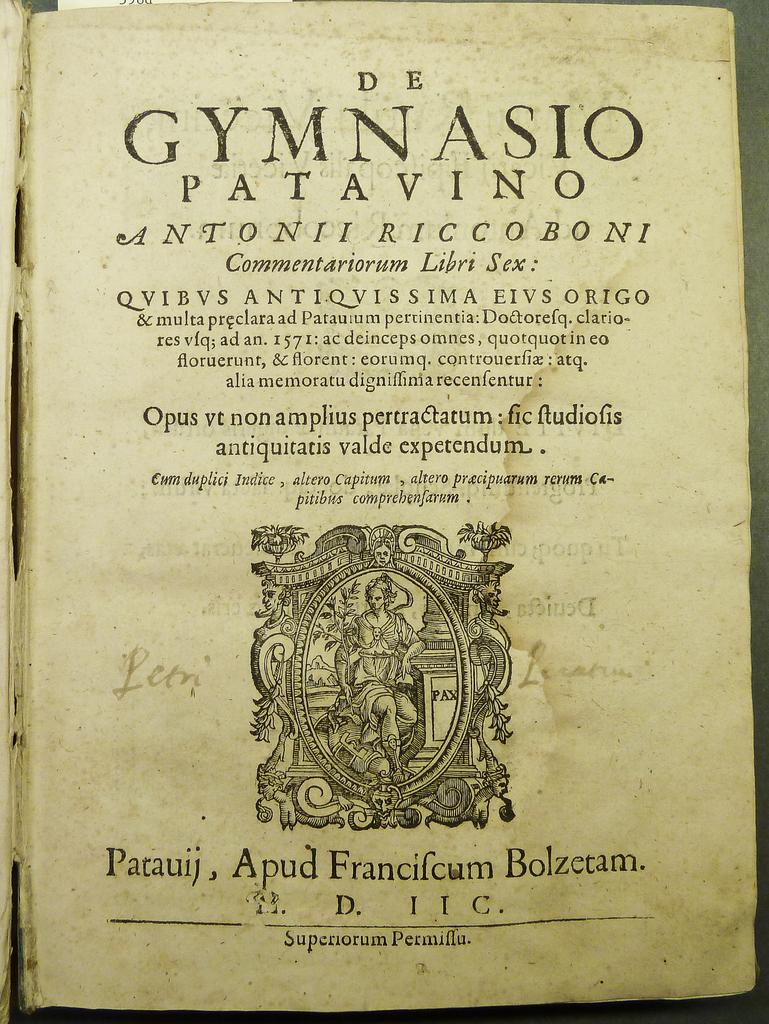Provide a one-sentence caption for the provided image. An old book cover with a title and text written in latin. 